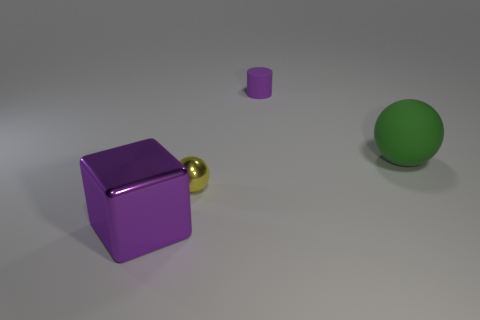Add 1 small spheres. How many objects exist? 5 Subtract all gray cylinders. Subtract all green cubes. How many cylinders are left? 1 Subtract all metallic balls. Subtract all big purple shiny things. How many objects are left? 2 Add 4 purple metallic things. How many purple metallic things are left? 5 Add 4 big purple metallic cubes. How many big purple metallic cubes exist? 5 Subtract 0 brown balls. How many objects are left? 4 Subtract all blocks. How many objects are left? 3 